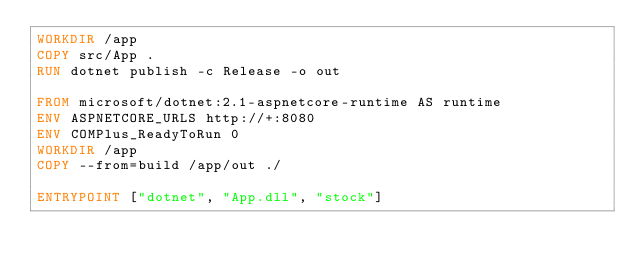<code> <loc_0><loc_0><loc_500><loc_500><_Dockerfile_>WORKDIR /app
COPY src/App .
RUN dotnet publish -c Release -o out

FROM microsoft/dotnet:2.1-aspnetcore-runtime AS runtime
ENV ASPNETCORE_URLS http://+:8080
ENV COMPlus_ReadyToRun 0
WORKDIR /app
COPY --from=build /app/out ./

ENTRYPOINT ["dotnet", "App.dll", "stock"]
</code> 